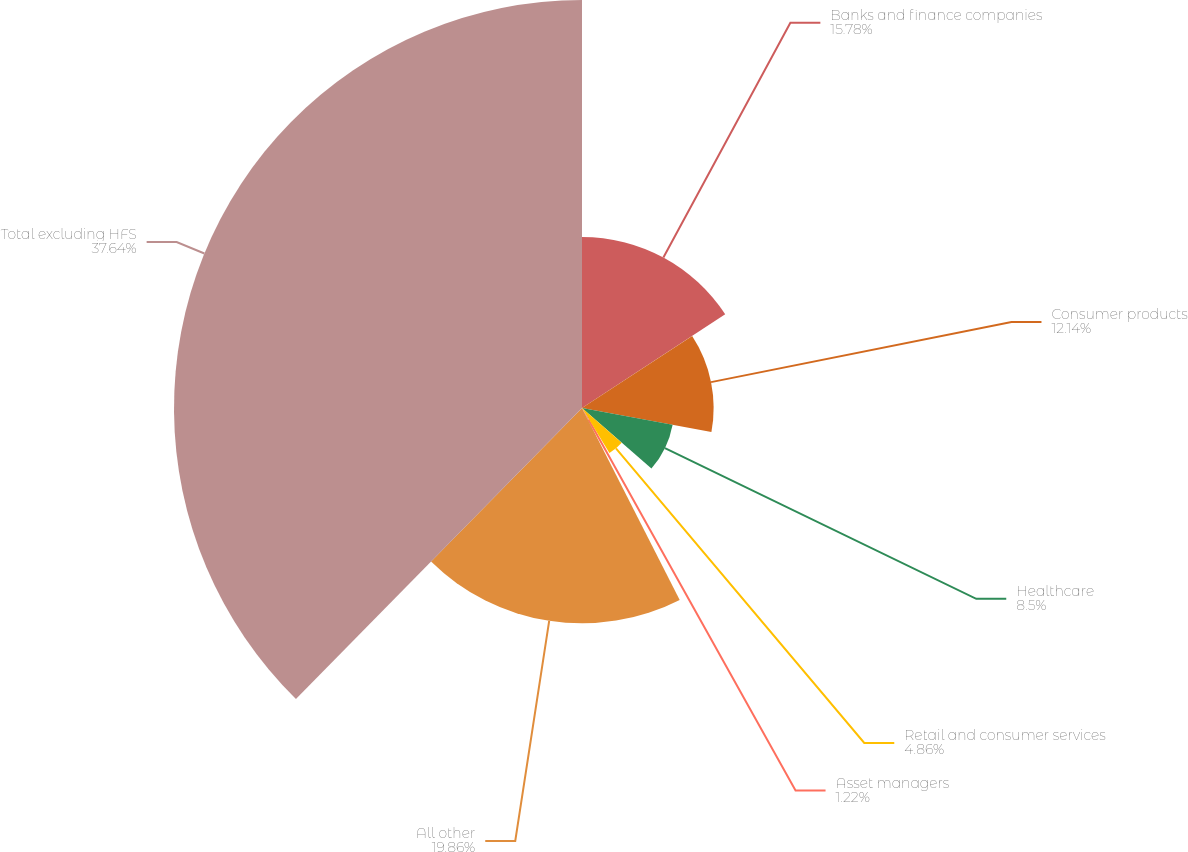Convert chart. <chart><loc_0><loc_0><loc_500><loc_500><pie_chart><fcel>Banks and finance companies<fcel>Consumer products<fcel>Healthcare<fcel>Retail and consumer services<fcel>Asset managers<fcel>All other<fcel>Total excluding HFS<nl><fcel>15.78%<fcel>12.14%<fcel>8.5%<fcel>4.86%<fcel>1.22%<fcel>19.86%<fcel>37.63%<nl></chart> 